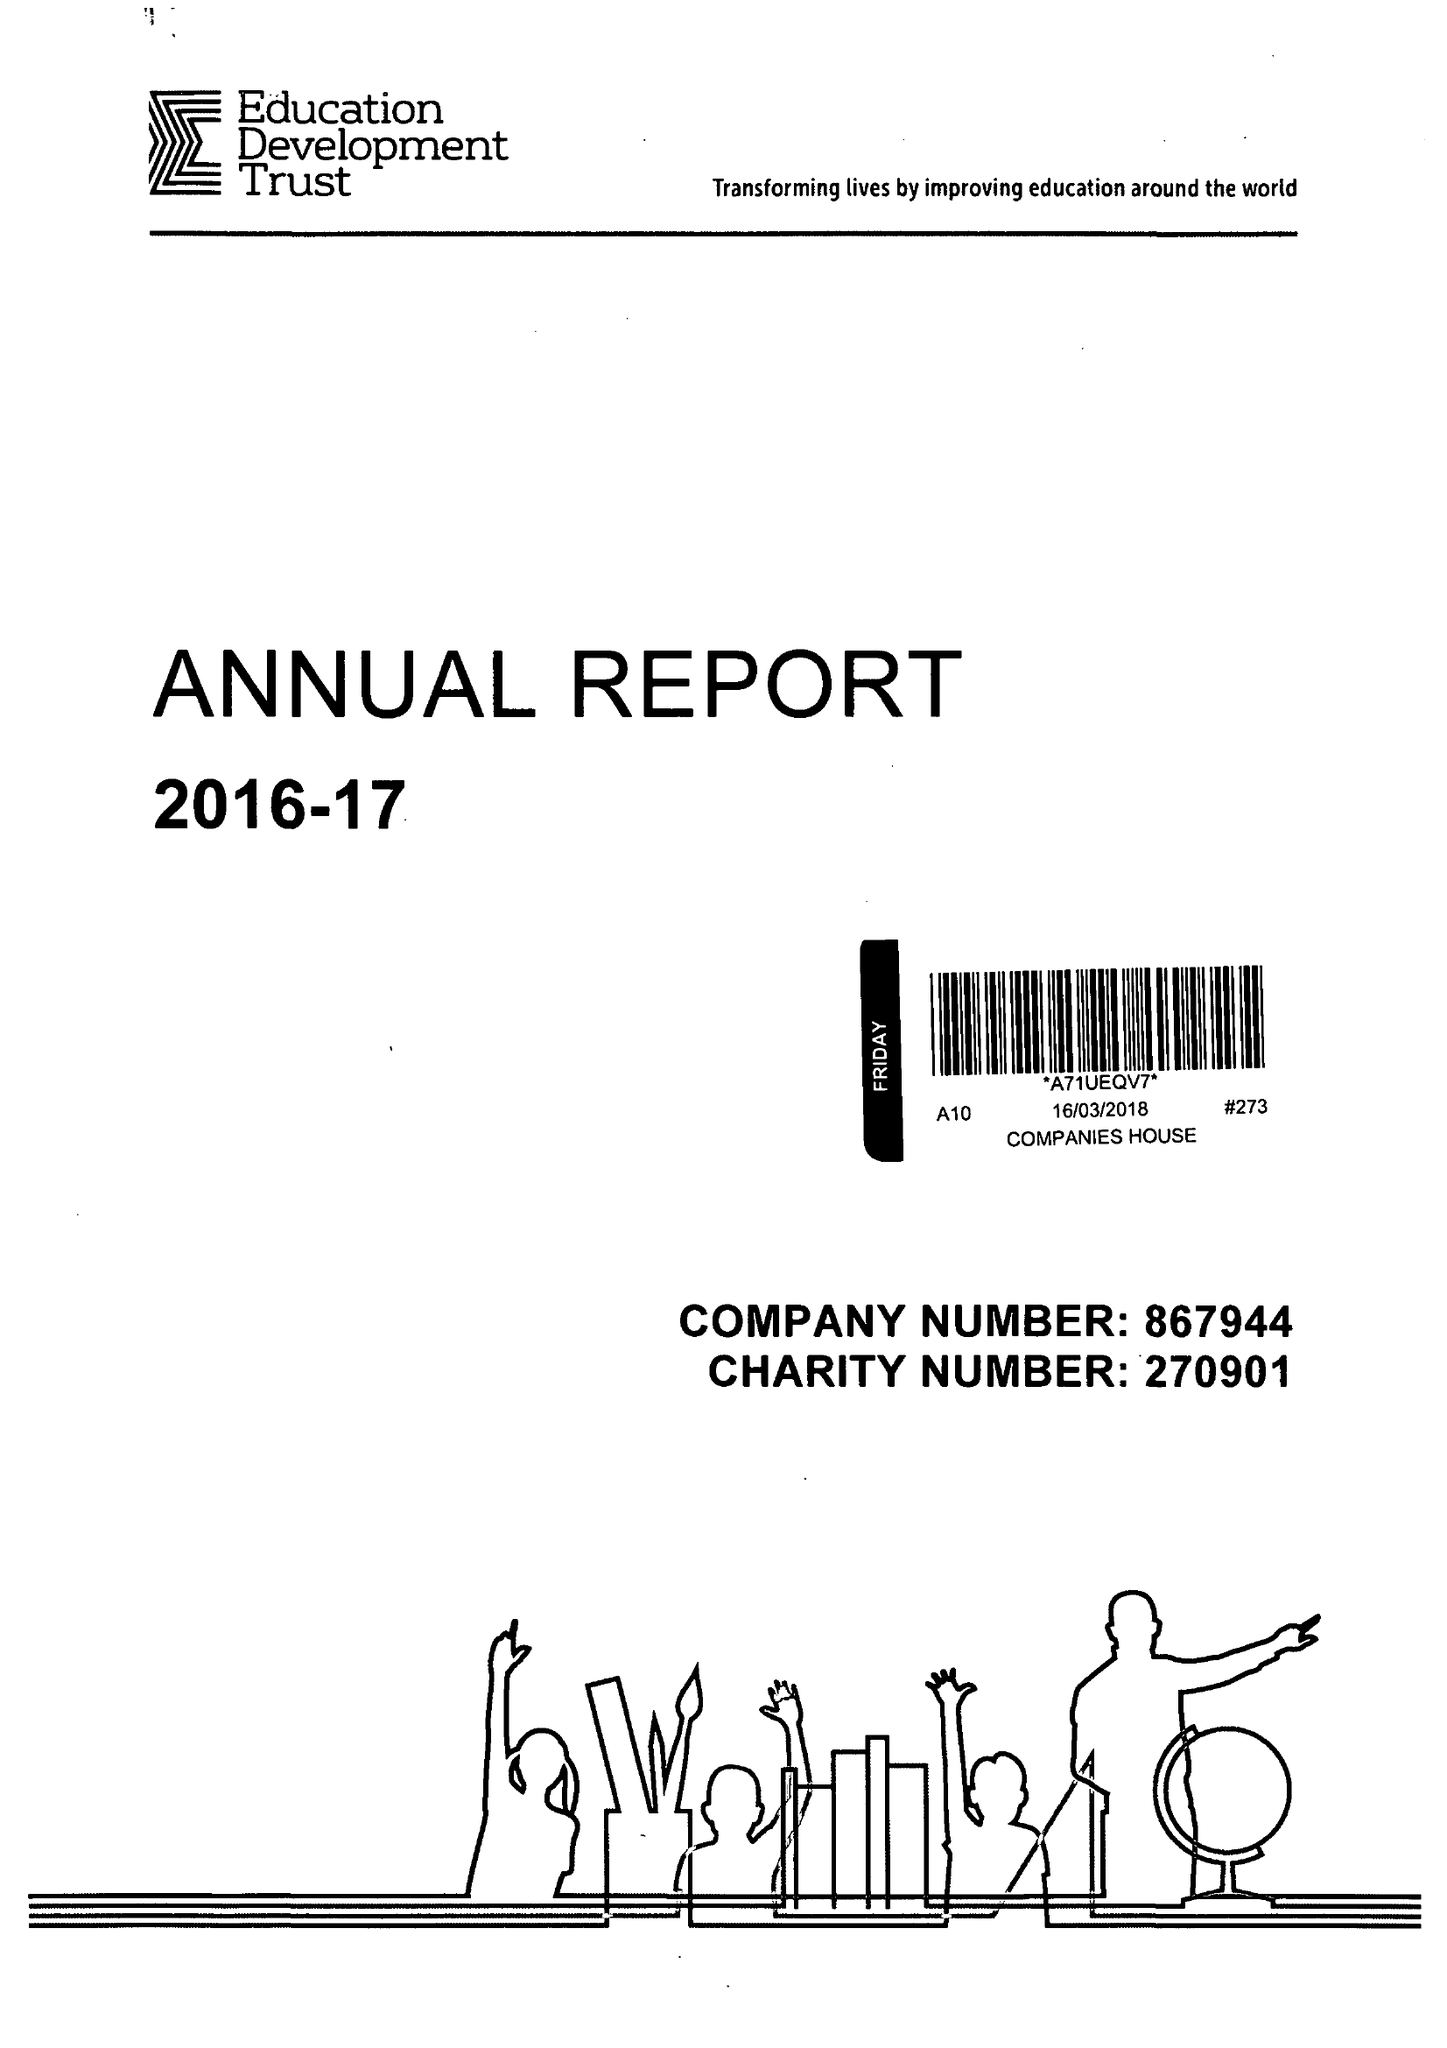What is the value for the address__postcode?
Answer the question using a single word or phrase. RG1 4RU 